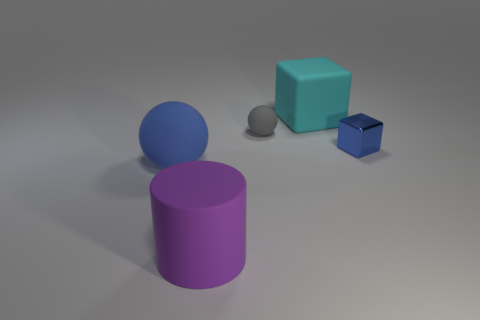Add 4 brown blocks. How many objects exist? 9 Subtract all blocks. How many objects are left? 3 Add 2 blocks. How many blocks are left? 4 Add 2 rubber cubes. How many rubber cubes exist? 3 Subtract 0 gray cylinders. How many objects are left? 5 Subtract all large rubber cylinders. Subtract all tiny blue cubes. How many objects are left? 3 